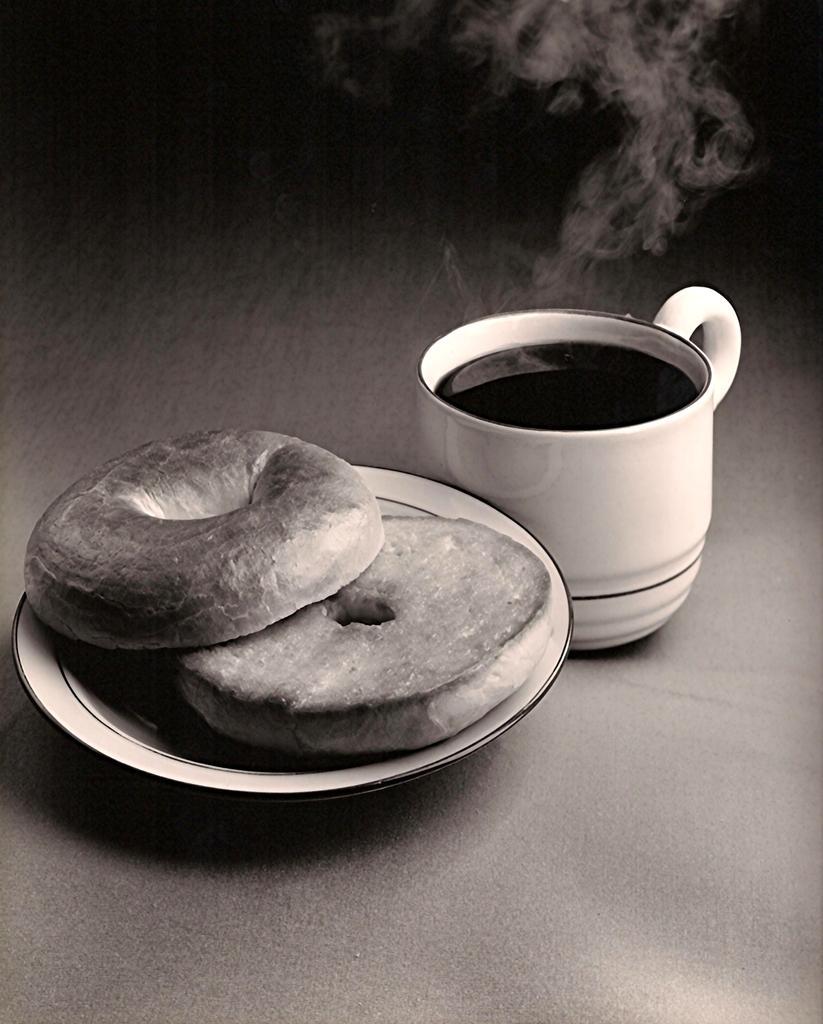Describe this image in one or two sentences. This is a black and white image. In this image we can see a cup of beverage and doughnuts in the serving plate. 